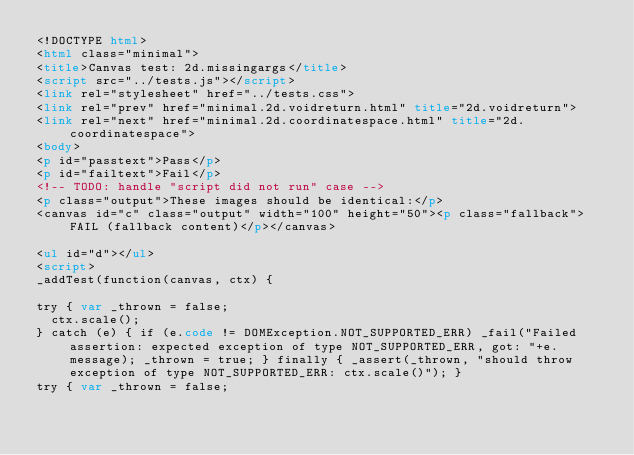Convert code to text. <code><loc_0><loc_0><loc_500><loc_500><_HTML_><!DOCTYPE html>
<html class="minimal">
<title>Canvas test: 2d.missingargs</title>
<script src="../tests.js"></script>
<link rel="stylesheet" href="../tests.css">
<link rel="prev" href="minimal.2d.voidreturn.html" title="2d.voidreturn">
<link rel="next" href="minimal.2d.coordinatespace.html" title="2d.coordinatespace">
<body>
<p id="passtext">Pass</p>
<p id="failtext">Fail</p>
<!-- TODO: handle "script did not run" case -->
<p class="output">These images should be identical:</p>
<canvas id="c" class="output" width="100" height="50"><p class="fallback">FAIL (fallback content)</p></canvas>

<ul id="d"></ul>
<script>
_addTest(function(canvas, ctx) {

try { var _thrown = false;
  ctx.scale();
} catch (e) { if (e.code != DOMException.NOT_SUPPORTED_ERR) _fail("Failed assertion: expected exception of type NOT_SUPPORTED_ERR, got: "+e.message); _thrown = true; } finally { _assert(_thrown, "should throw exception of type NOT_SUPPORTED_ERR: ctx.scale()"); }
try { var _thrown = false;</code> 